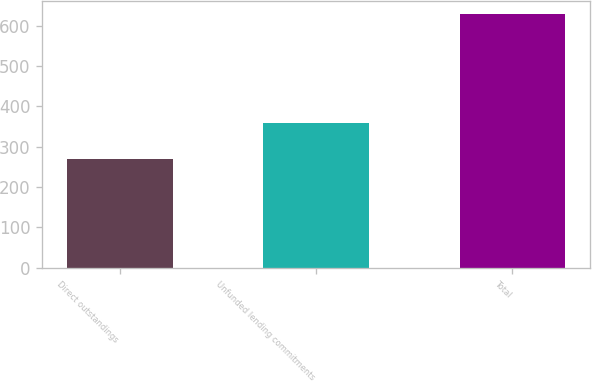Convert chart. <chart><loc_0><loc_0><loc_500><loc_500><bar_chart><fcel>Direct outstandings<fcel>Unfunded lending commitments<fcel>Total<nl><fcel>270<fcel>359<fcel>629<nl></chart> 